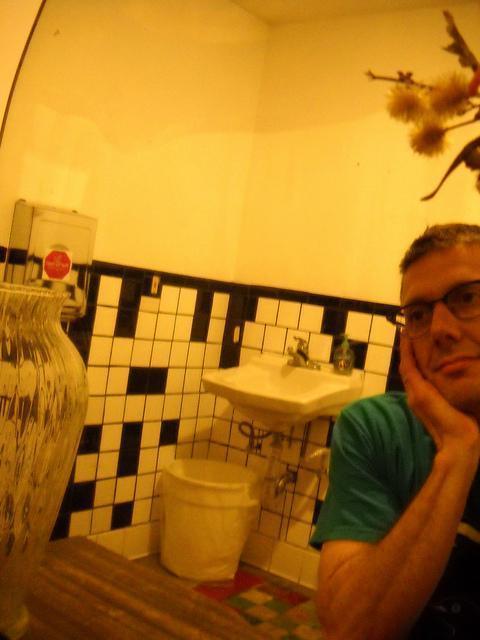How many zebras are facing forward?
Give a very brief answer. 0. 